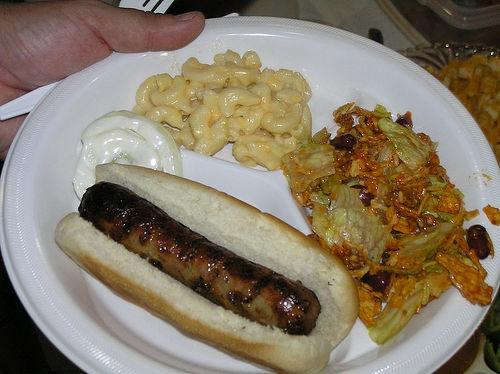Do this look yummy?
Concise answer only. Yes. Is this healthy?
Short answer required. No. What is the side dish?
Be succinct. Mac and cheese. 